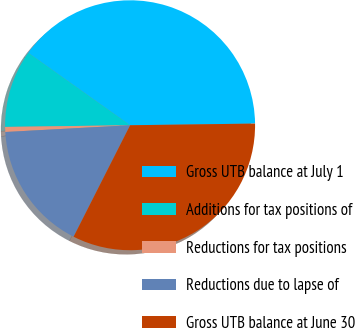<chart> <loc_0><loc_0><loc_500><loc_500><pie_chart><fcel>Gross UTB balance at July 1<fcel>Additions for tax positions of<fcel>Reductions for tax positions<fcel>Reductions due to lapse of<fcel>Gross UTB balance at June 30<nl><fcel>39.95%<fcel>10.05%<fcel>0.65%<fcel>16.67%<fcel>32.68%<nl></chart> 